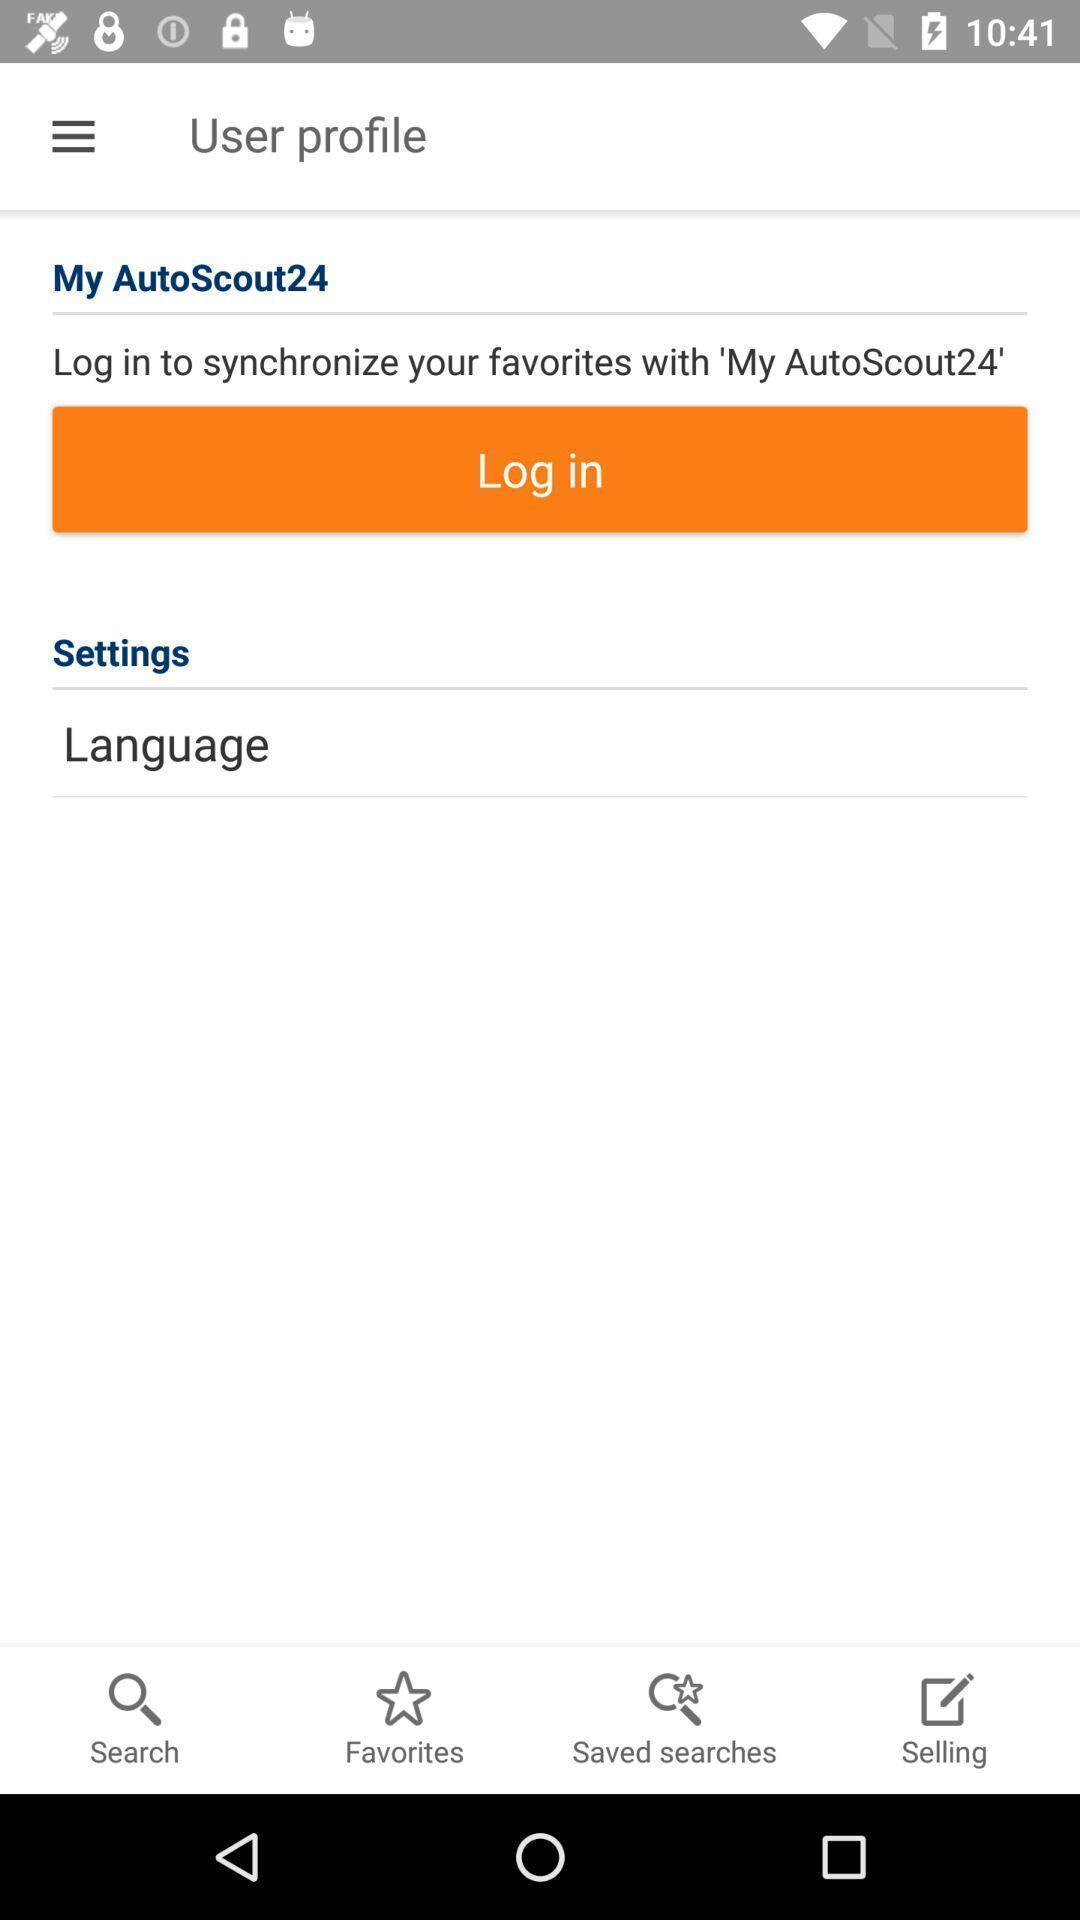Give me a narrative description of this picture. Screen displaying user profile with various options. 